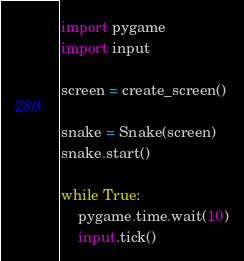Convert code to text. <code><loc_0><loc_0><loc_500><loc_500><_Python_>import pygame
import input

screen = create_screen()

snake = Snake(screen)
snake.start()

while True:
	pygame.time.wait(10)
	input.tick()</code> 